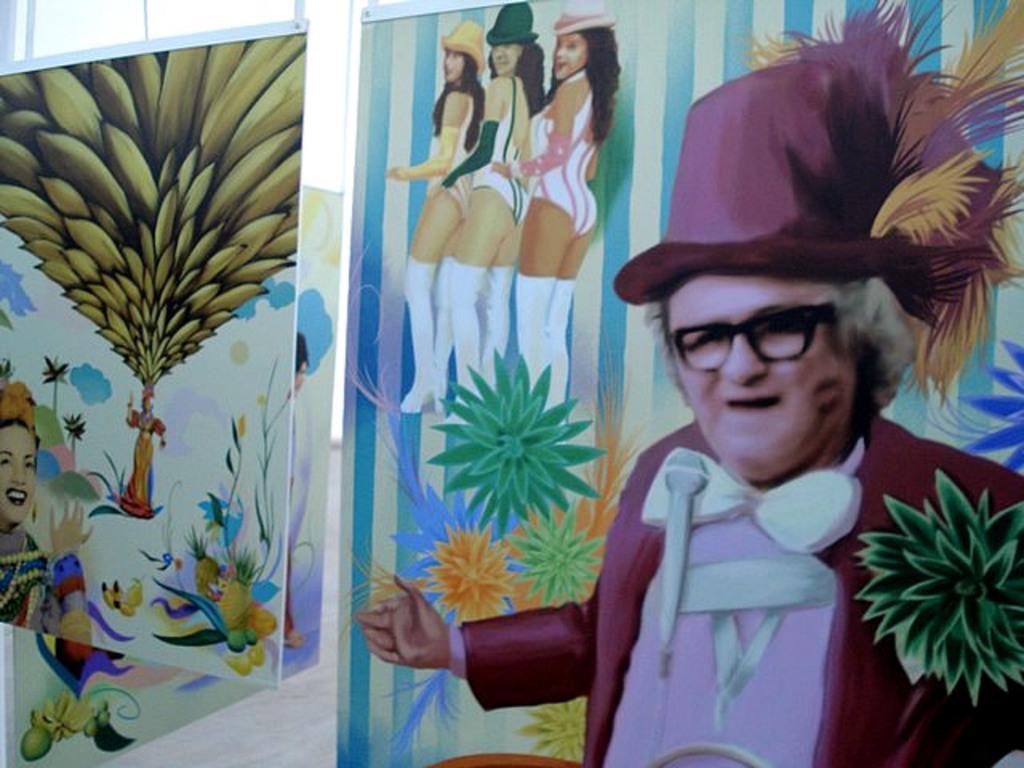Describe this image in one or two sentences. In this image I can see few boards with painting on them. I can see a person wearing pink jacket, pink hat and black spectacles and few women standing. On the other board I can see a person smiling and few other objects. In the background I can see the sky and the floor. 